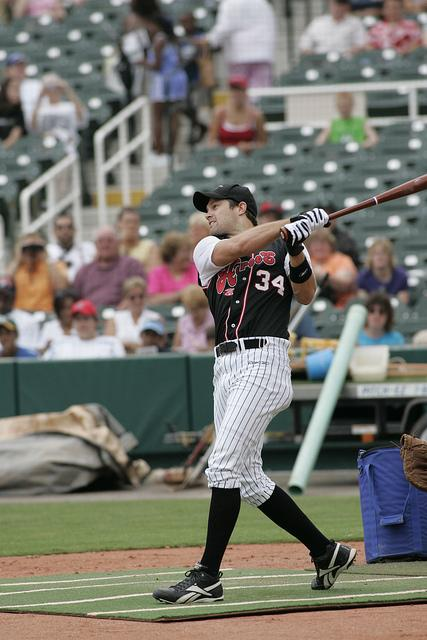Why is the player wearing gloves? Please explain your reasoning. grip. The gloves are athletic and intended for baseball games.  a baseball is slippery, so gloves intended for baseball have this feature. 